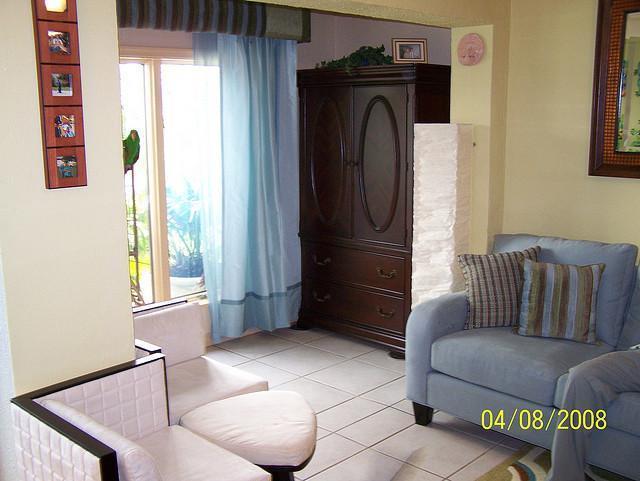How many chairs are visible?
Give a very brief answer. 2. How many couches are there?
Give a very brief answer. 2. 